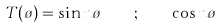<formula> <loc_0><loc_0><loc_500><loc_500>T ( \tau ) = \sin n \tau \quad ; \quad \cos n \tau</formula> 